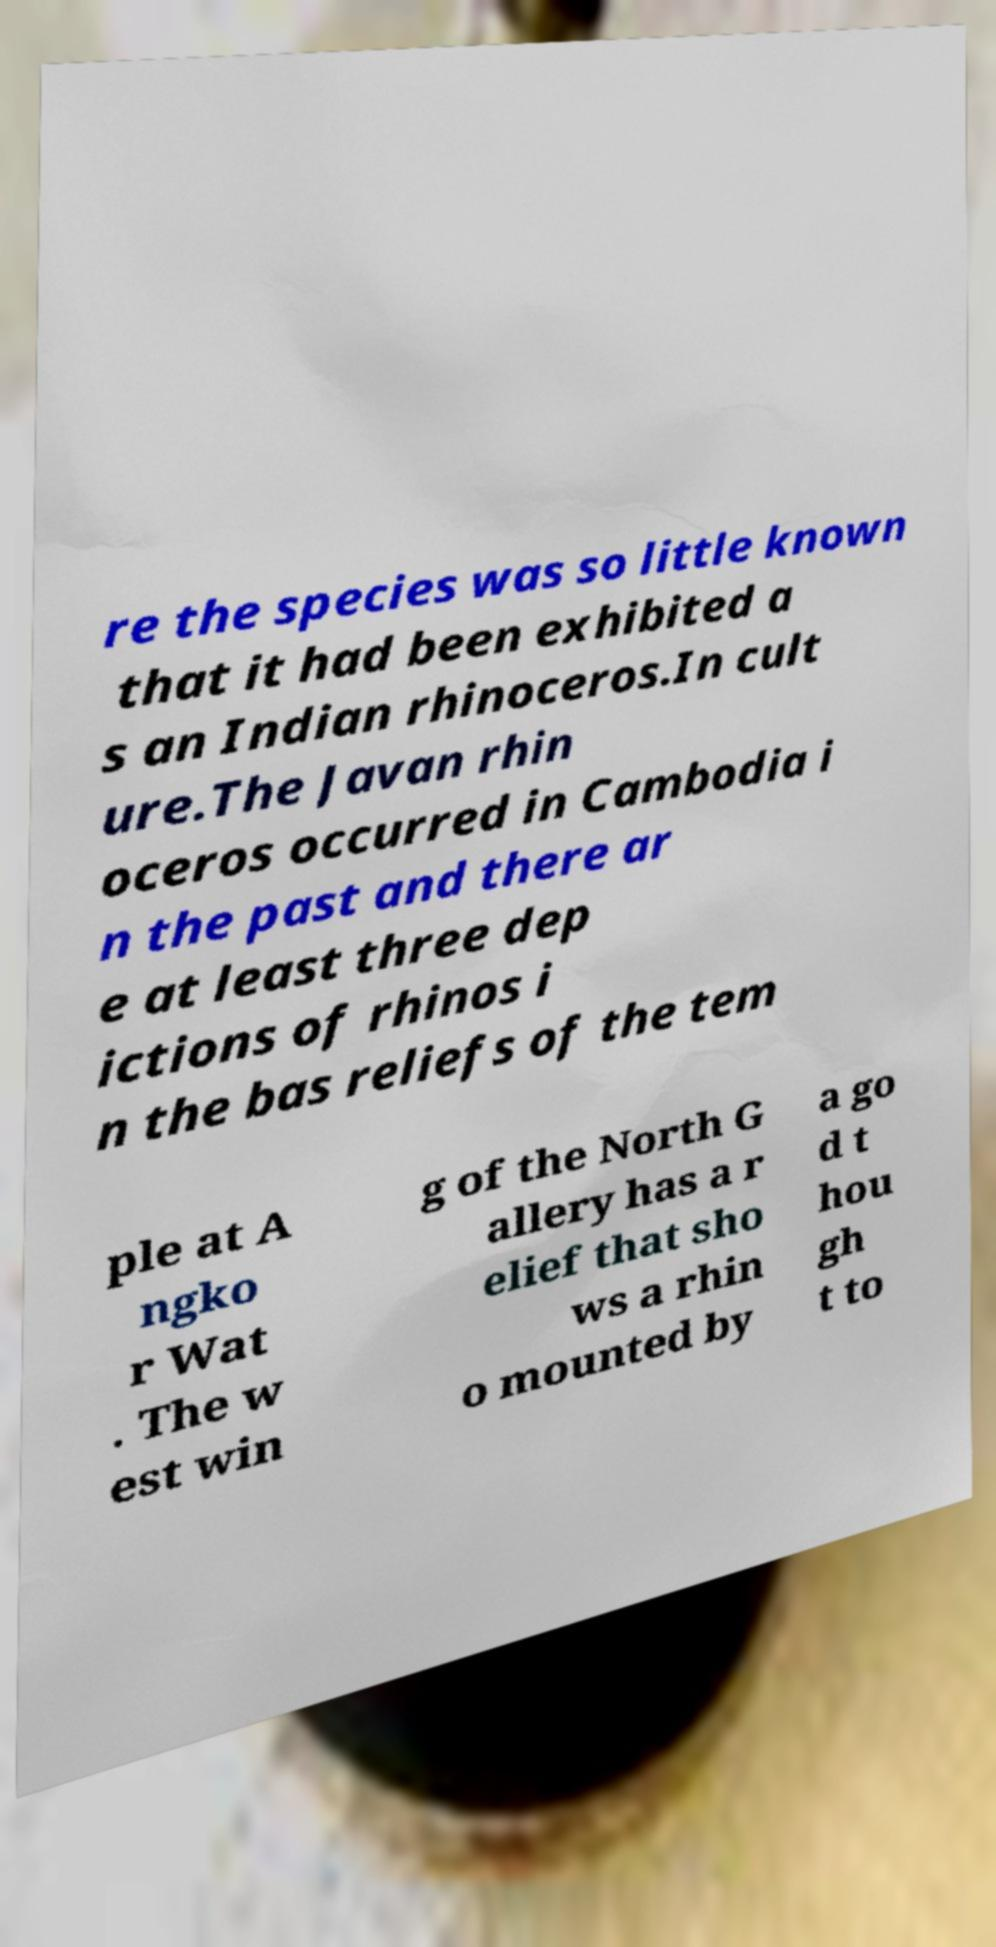Please read and relay the text visible in this image. What does it say? re the species was so little known that it had been exhibited a s an Indian rhinoceros.In cult ure.The Javan rhin oceros occurred in Cambodia i n the past and there ar e at least three dep ictions of rhinos i n the bas reliefs of the tem ple at A ngko r Wat . The w est win g of the North G allery has a r elief that sho ws a rhin o mounted by a go d t hou gh t to 